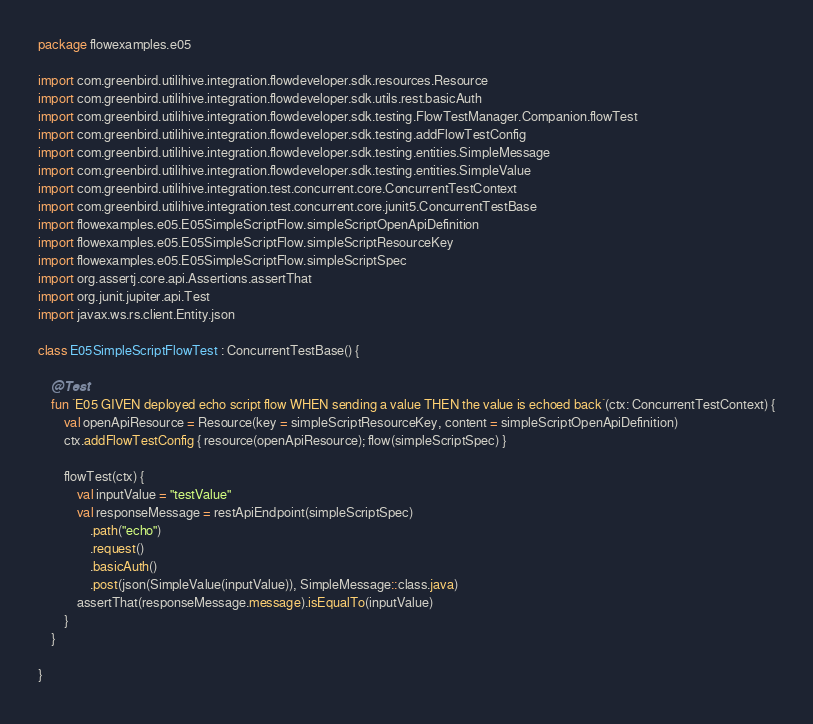Convert code to text. <code><loc_0><loc_0><loc_500><loc_500><_Kotlin_>package flowexamples.e05

import com.greenbird.utilihive.integration.flowdeveloper.sdk.resources.Resource
import com.greenbird.utilihive.integration.flowdeveloper.sdk.utils.rest.basicAuth
import com.greenbird.utilihive.integration.flowdeveloper.sdk.testing.FlowTestManager.Companion.flowTest
import com.greenbird.utilihive.integration.flowdeveloper.sdk.testing.addFlowTestConfig
import com.greenbird.utilihive.integration.flowdeveloper.sdk.testing.entities.SimpleMessage
import com.greenbird.utilihive.integration.flowdeveloper.sdk.testing.entities.SimpleValue
import com.greenbird.utilihive.integration.test.concurrent.core.ConcurrentTestContext
import com.greenbird.utilihive.integration.test.concurrent.core.junit5.ConcurrentTestBase
import flowexamples.e05.E05SimpleScriptFlow.simpleScriptOpenApiDefinition
import flowexamples.e05.E05SimpleScriptFlow.simpleScriptResourceKey
import flowexamples.e05.E05SimpleScriptFlow.simpleScriptSpec
import org.assertj.core.api.Assertions.assertThat
import org.junit.jupiter.api.Test
import javax.ws.rs.client.Entity.json

class E05SimpleScriptFlowTest : ConcurrentTestBase() {

    @Test
    fun `E05 GIVEN deployed echo script flow WHEN sending a value THEN the value is echoed back`(ctx: ConcurrentTestContext) {
        val openApiResource = Resource(key = simpleScriptResourceKey, content = simpleScriptOpenApiDefinition)
        ctx.addFlowTestConfig { resource(openApiResource); flow(simpleScriptSpec) }

        flowTest(ctx) {
            val inputValue = "testValue"
            val responseMessage = restApiEndpoint(simpleScriptSpec)
                .path("echo")
                .request()
                .basicAuth()
                .post(json(SimpleValue(inputValue)), SimpleMessage::class.java)
            assertThat(responseMessage.message).isEqualTo(inputValue)
        }
    }

}
</code> 